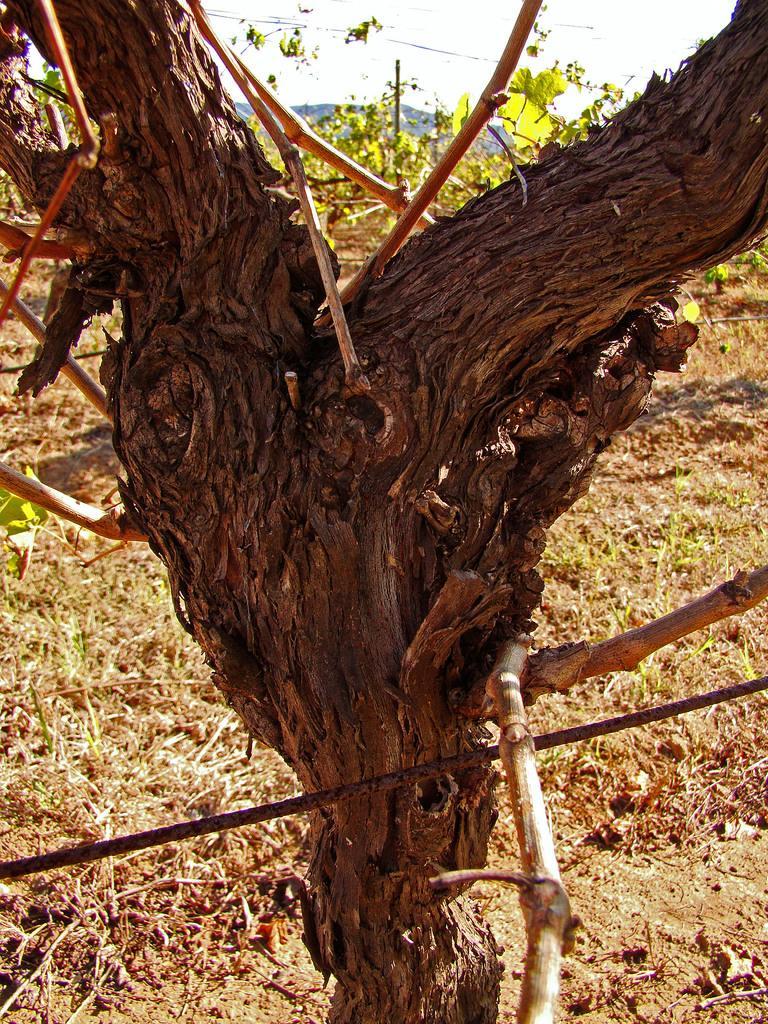Could you give a brief overview of what you see in this image? In this picture there is a trunk in the center of the image. 